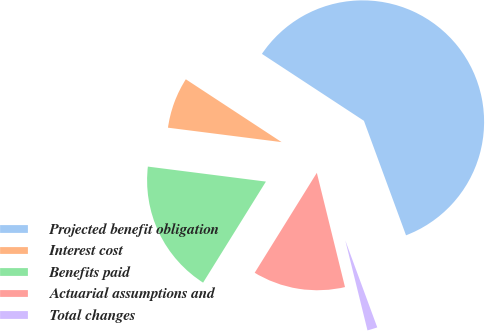Convert chart to OTSL. <chart><loc_0><loc_0><loc_500><loc_500><pie_chart><fcel>Projected benefit obligation<fcel>Interest cost<fcel>Benefits paid<fcel>Actuarial assumptions and<fcel>Total changes<nl><fcel>60.15%<fcel>7.23%<fcel>18.16%<fcel>12.7%<fcel>1.76%<nl></chart> 